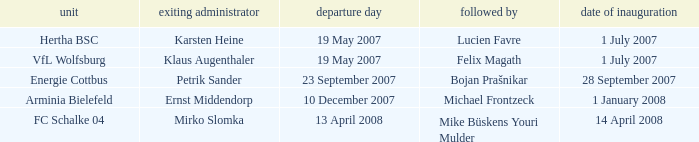I'm looking to parse the entire table for insights. Could you assist me with that? {'header': ['unit', 'exiting administrator', 'departure day', 'followed by', 'date of inauguration'], 'rows': [['Hertha BSC', 'Karsten Heine', '19 May 2007', 'Lucien Favre', '1 July 2007'], ['VfL Wolfsburg', 'Klaus Augenthaler', '19 May 2007', 'Felix Magath', '1 July 2007'], ['Energie Cottbus', 'Petrik Sander', '23 September 2007', 'Bojan Prašnikar', '28 September 2007'], ['Arminia Bielefeld', 'Ernst Middendorp', '10 December 2007', 'Michael Frontzeck', '1 January 2008'], ['FC Schalke 04', 'Mirko Slomka', '13 April 2008', 'Mike Büskens Youri Mulder', '14 April 2008']]} When was the departure date when a manager was replaced by Bojan Prašnikar? 23 September 2007. 